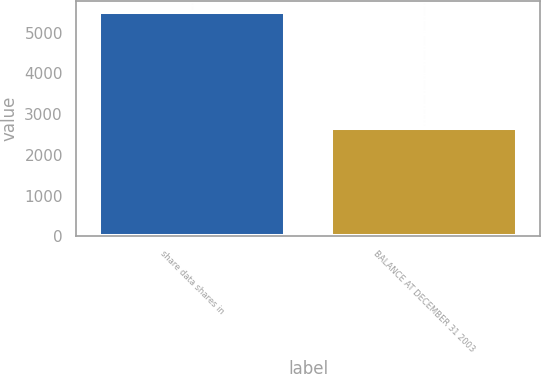Convert chart to OTSL. <chart><loc_0><loc_0><loc_500><loc_500><bar_chart><fcel>share data shares in<fcel>BALANCE AT DECEMBER 31 2003<nl><fcel>5508<fcel>2658<nl></chart> 